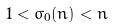Convert formula to latex. <formula><loc_0><loc_0><loc_500><loc_500>1 < \sigma _ { 0 } ( n ) < n</formula> 